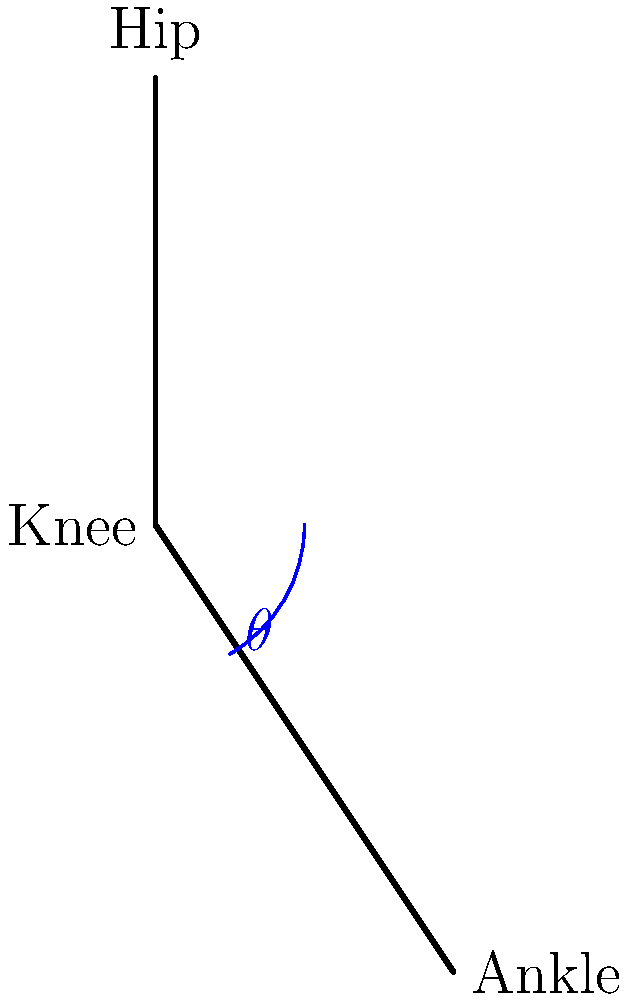Given the motion capture data represented by the stick figure above, calculate the knee joint angle $\theta$ using Python. Assume the coordinates are in centimeters and the origin (0,0) is at the hip joint. How would you approach this problem using vector calculations? To calculate the knee joint angle $\theta$ using Python and vector calculations, follow these steps:

1. Define the vectors:
   - Vector from knee to hip: $\vec{v_1} = (0, 3)$
   - Vector from knee to ankle: $\vec{v_2} = (2, -3)$

2. Calculate the dot product of these vectors:
   $$\vec{v_1} \cdot \vec{v_2} = 0 \cdot 2 + 3 \cdot (-3) = -9$$

3. Calculate the magnitudes of the vectors:
   $$|\vec{v_1}| = \sqrt{0^2 + 3^2} = 3$$
   $$|\vec{v_2}| = \sqrt{2^2 + (-3)^2} = \sqrt{13}$$

4. Use the dot product formula to find the cosine of the angle:
   $$\cos(\theta) = \frac{\vec{v_1} \cdot \vec{v_2}}{|\vec{v_1}||\vec{v_2}|} = \frac{-9}{3\sqrt{13}}$$

5. Calculate the angle using the arccosine function:
   $$\theta = \arccos(\frac{-9}{3\sqrt{13}})$$

In Python, you would implement this as follows:

```python
import numpy as np

v1 = np.array([0, 3])
v2 = np.array([2, -3])

dot_product = np.dot(v1, v2)
magnitude_v1 = np.linalg.norm(v1)
magnitude_v2 = np.linalg.norm(v2)

cos_theta = dot_product / (magnitude_v1 * magnitude_v2)
theta_radians = np.arccos(cos_theta)
theta_degrees = np.degrees(theta_radians)

print(f"Knee joint angle: {theta_degrees:.2f} degrees")
```

This approach uses NumPy for efficient vector operations and trigonometric calculations.
Answer: $\theta = \arccos(\frac{-9}{3\sqrt{13}}) \approx 119.74°$ 